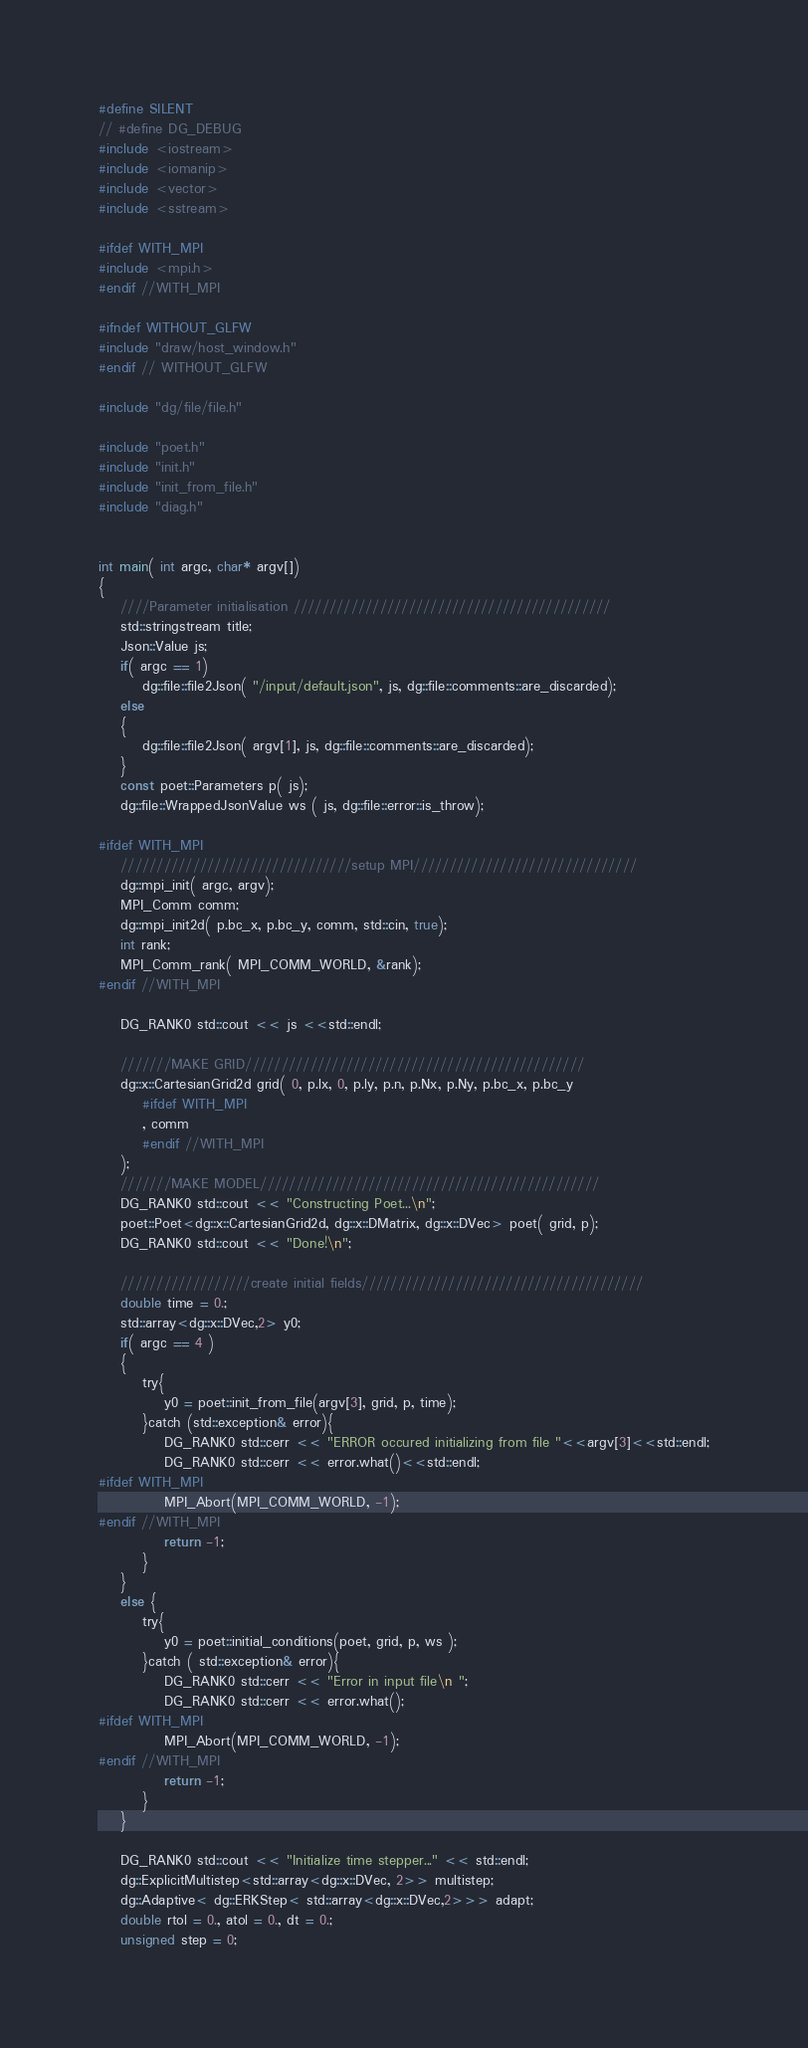<code> <loc_0><loc_0><loc_500><loc_500><_Cuda_>#define SILENT
// #define DG_DEBUG
#include <iostream>
#include <iomanip>
#include <vector>
#include <sstream>

#ifdef WITH_MPI
#include <mpi.h>
#endif //WITH_MPI

#ifndef WITHOUT_GLFW
#include "draw/host_window.h"
#endif // WITHOUT_GLFW

#include "dg/file/file.h"

#include "poet.h"
#include "init.h"
#include "init_from_file.h"
#include "diag.h"


int main( int argc, char* argv[])
{
    ////Parameter initialisation ////////////////////////////////////////////
    std::stringstream title;
    Json::Value js;
    if( argc == 1)
        dg::file::file2Json( "/input/default.json", js, dg::file::comments::are_discarded);
    else
    {
        dg::file::file2Json( argv[1], js, dg::file::comments::are_discarded);
    }
    const poet::Parameters p( js);
    dg::file::WrappedJsonValue ws ( js, dg::file::error::is_throw);  
    
#ifdef WITH_MPI
    ////////////////////////////////setup MPI///////////////////////////////
    dg::mpi_init( argc, argv);
    MPI_Comm comm;
    dg::mpi_init2d( p.bc_x, p.bc_y, comm, std::cin, true);
    int rank;
    MPI_Comm_rank( MPI_COMM_WORLD, &rank);
#endif //WITH_MPI

    DG_RANK0 std::cout << js <<std::endl;

    ///////MAKE GRID///////////////////////////////////////////////
    dg::x::CartesianGrid2d grid( 0, p.lx, 0, p.ly, p.n, p.Nx, p.Ny, p.bc_x, p.bc_y
        #ifdef WITH_MPI
        , comm
        #endif //WITH_MPI
    );
    ///////MAKE MODEL///////////////////////////////////////////////
    DG_RANK0 std::cout << "Constructing Poet...\n";
    poet::Poet<dg::x::CartesianGrid2d, dg::x::DMatrix, dg::x::DVec> poet( grid, p);
    DG_RANK0 std::cout << "Done!\n";

    //////////////////create initial fields///////////////////////////////////////
    double time = 0.;
    std::array<dg::x::DVec,2> y0;
    if( argc == 4 )
    {
        try{
            y0 = poet::init_from_file(argv[3], grid, p, time);
        }catch (std::exception& error){
            DG_RANK0 std::cerr << "ERROR occured initializing from file "<<argv[3]<<std::endl;
            DG_RANK0 std::cerr << error.what()<<std::endl;
#ifdef WITH_MPI
            MPI_Abort(MPI_COMM_WORLD, -1);
#endif //WITH_MPI
            return -1;
        }
    }
    else {
        try{
            y0 = poet::initial_conditions(poet, grid, p, ws );
        }catch ( std::exception& error){
            DG_RANK0 std::cerr << "Error in input file\n ";
            DG_RANK0 std::cerr << error.what();
#ifdef WITH_MPI
            MPI_Abort(MPI_COMM_WORLD, -1);
#endif //WITH_MPI
            return -1;
        }
    }
    
    DG_RANK0 std::cout << "Initialize time stepper..." << std::endl;
    dg::ExplicitMultistep<std::array<dg::x::DVec, 2>> multistep;
    dg::Adaptive< dg::ERKStep< std::array<dg::x::DVec,2>>> adapt;
    double rtol = 0., atol = 0., dt = 0.;
    unsigned step = 0;</code> 